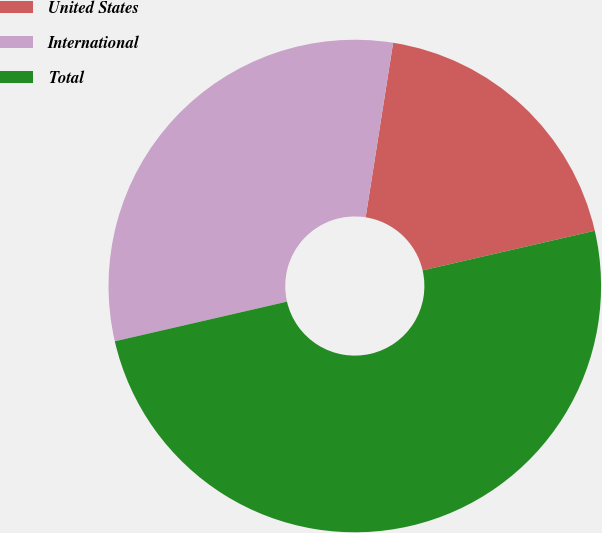Convert chart. <chart><loc_0><loc_0><loc_500><loc_500><pie_chart><fcel>United States<fcel>International<fcel>Total<nl><fcel>18.91%<fcel>31.09%<fcel>50.0%<nl></chart> 